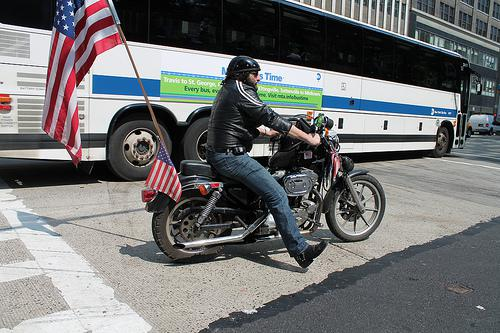Question: where is the motorcycle?
Choices:
A. On the curb.
B. On the sidewalk.
C. In a parking spot.
D. Near a bus.
Answer with the letter. Answer: D Question: what is the man wearing on his head?
Choices:
A. A hat.
B. Sunglasses.
C. A bandana.
D. A helmet.
Answer with the letter. Answer: D Question: where was this picture taken?
Choices:
A. In the city.
B. In the country.
C. At the lake.
D. On the beach.
Answer with the letter. Answer: A 